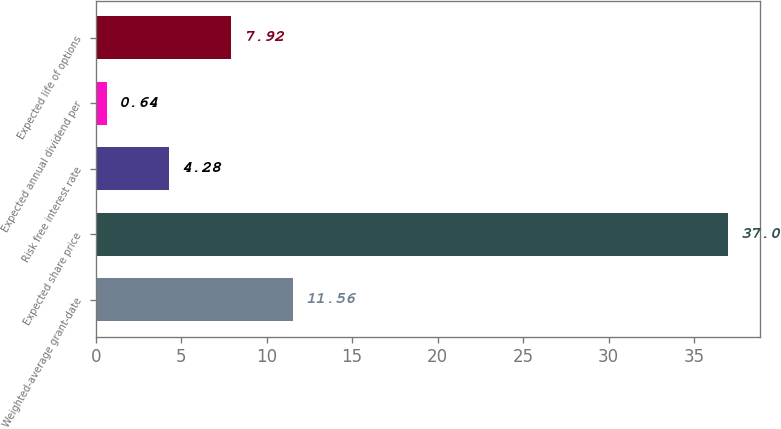Convert chart to OTSL. <chart><loc_0><loc_0><loc_500><loc_500><bar_chart><fcel>Weighted-average grant-date<fcel>Expected share price<fcel>Risk free interest rate<fcel>Expected annual dividend per<fcel>Expected life of options<nl><fcel>11.56<fcel>37<fcel>4.28<fcel>0.64<fcel>7.92<nl></chart> 